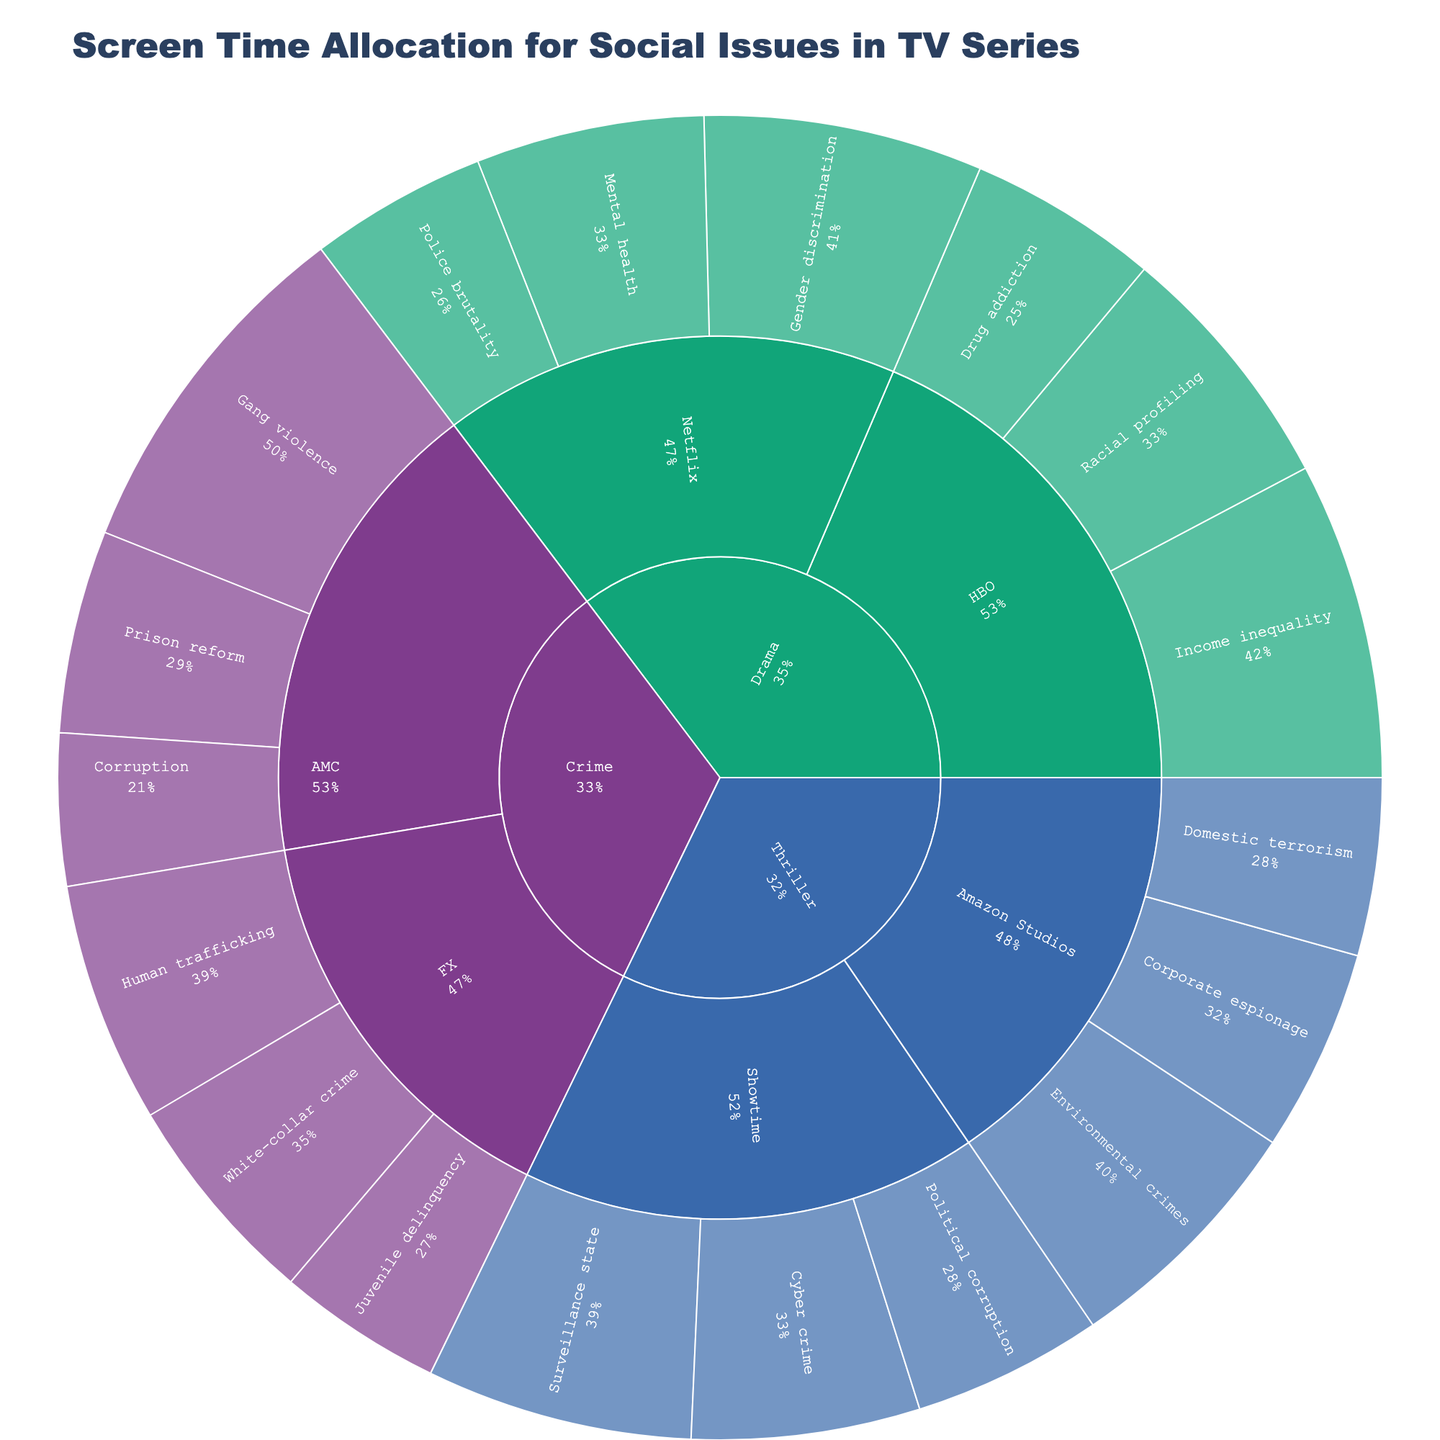What genre has the most representation of the social issue "Income inequality"? To find this, we look at the segments in the sunburst plot that represent "Income inequality" and see which genre they fall under. We see that "Income inequality" is represented in the Drama genre.
Answer: Drama What is the total screen time dedicated to social issues in FX's Crime genre? First, locate the FX sector within the Crime genre. Then sum the screen times for all FX's social issues: Human trafficking (19), White-collar crime (17), and Juvenile delinquency (13). The total is 19 + 17 + 13 = 49.
Answer: 49 Which social issue within HBO has the highest screen time and what is its value? Check HBO's segments in the Drama genre. Compare the screen times: Income inequality (25), Racial profiling (20), and Drug addiction (15). Income inequality is the highest with a value of 25.
Answer: Income inequality, 25 How does the representation of gender discrimination in Netflix's Drama compare to the representation of drug addiction in HBO's Drama? Locate the segments within Drama for HBO and Netflix respectively. Compare the screen times: Gender discrimination in Netflix is 22, while Drug addiction in HBO is 15. 22 is greater than 15.
Answer: Gender discrimination in Netflix is greater What is the average screen time for all social issues represented by AMC? Add the screen times for AMC's social issues: Gang violence (28), Prison reform (16), and Corruption (12). The sum is 28 + 16 + 12 = 56, and there are 3 social issues. The average is 56 / 3 ≈ 18.67.
Answer: 18.67 Which production company has the least representation of social issues within the Thriller genre? Look at the Thriller segments and compare the screen times for Showtime and Amazon Studios. Add up the screen times: Showtime (21+18+15) = 54, Amazon Studios (20+16+14) = 50. Amazon Studios has less total screen time.
Answer: Amazon Studios What is the total screen time for Police brutality and Domestic terrorism combined? Locate the social issues: Police brutality in Netflix's Drama and Domestic terrorism in Amazon Studios' Thriller. Add their screen times: 14 (Police brutality) + 14 (Domestic terrorism) = 28.
Answer: 28 Which genre has the greatest diversity in social issues representation in terms of the number of different social issues depicted? Count the number of different social issues within each genre: Drama (6), Crime (6), and Thriller (6). Each genre has 6 different social issues represented.
Answer: All genres have equal diversity 